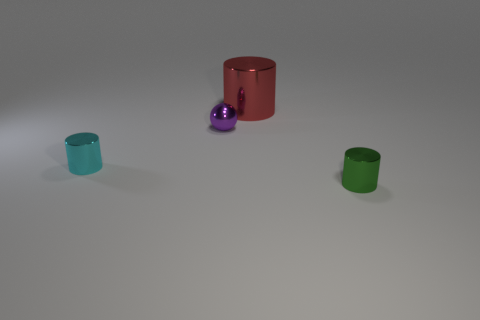Is there a large metallic cylinder of the same color as the small ball?
Make the answer very short. No. Is there a green metal cylinder?
Your response must be concise. Yes. There is a small cylinder that is right of the big metallic cylinder; what is its color?
Make the answer very short. Green. There is a purple metal thing; is its size the same as the thing that is on the left side of the purple metallic ball?
Make the answer very short. Yes. There is a metallic thing that is right of the ball and in front of the purple object; what size is it?
Make the answer very short. Small. Is there a large red object that has the same material as the small sphere?
Your answer should be compact. Yes. What is the shape of the tiny green thing?
Offer a terse response. Cylinder. Do the cyan shiny thing and the purple thing have the same size?
Provide a short and direct response. Yes. What number of other objects are the same shape as the purple metal object?
Your answer should be compact. 0. What shape is the small thing that is behind the cyan cylinder?
Give a very brief answer. Sphere. 